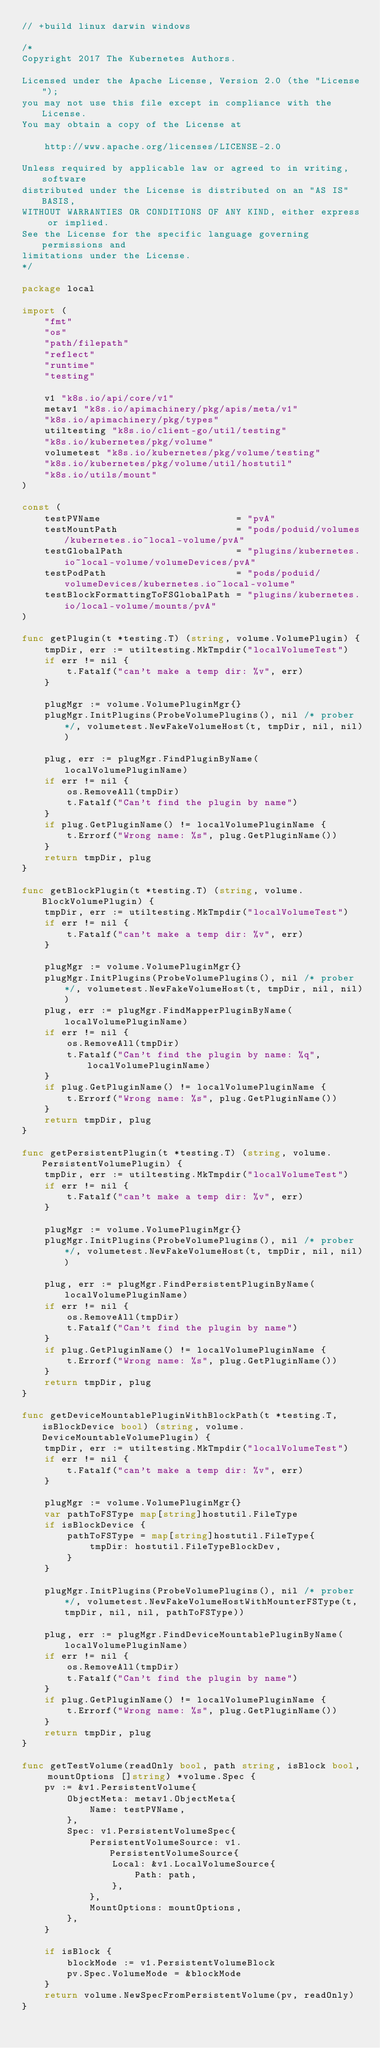Convert code to text. <code><loc_0><loc_0><loc_500><loc_500><_Go_>// +build linux darwin windows

/*
Copyright 2017 The Kubernetes Authors.

Licensed under the Apache License, Version 2.0 (the "License");
you may not use this file except in compliance with the License.
You may obtain a copy of the License at

    http://www.apache.org/licenses/LICENSE-2.0

Unless required by applicable law or agreed to in writing, software
distributed under the License is distributed on an "AS IS" BASIS,
WITHOUT WARRANTIES OR CONDITIONS OF ANY KIND, either express or implied.
See the License for the specific language governing permissions and
limitations under the License.
*/

package local

import (
	"fmt"
	"os"
	"path/filepath"
	"reflect"
	"runtime"
	"testing"

	v1 "k8s.io/api/core/v1"
	metav1 "k8s.io/apimachinery/pkg/apis/meta/v1"
	"k8s.io/apimachinery/pkg/types"
	utiltesting "k8s.io/client-go/util/testing"
	"k8s.io/kubernetes/pkg/volume"
	volumetest "k8s.io/kubernetes/pkg/volume/testing"
	"k8s.io/kubernetes/pkg/volume/util/hostutil"
	"k8s.io/utils/mount"
)

const (
	testPVName                        = "pvA"
	testMountPath                     = "pods/poduid/volumes/kubernetes.io~local-volume/pvA"
	testGlobalPath                    = "plugins/kubernetes.io~local-volume/volumeDevices/pvA"
	testPodPath                       = "pods/poduid/volumeDevices/kubernetes.io~local-volume"
	testBlockFormattingToFSGlobalPath = "plugins/kubernetes.io/local-volume/mounts/pvA"
)

func getPlugin(t *testing.T) (string, volume.VolumePlugin) {
	tmpDir, err := utiltesting.MkTmpdir("localVolumeTest")
	if err != nil {
		t.Fatalf("can't make a temp dir: %v", err)
	}

	plugMgr := volume.VolumePluginMgr{}
	plugMgr.InitPlugins(ProbeVolumePlugins(), nil /* prober */, volumetest.NewFakeVolumeHost(t, tmpDir, nil, nil))

	plug, err := plugMgr.FindPluginByName(localVolumePluginName)
	if err != nil {
		os.RemoveAll(tmpDir)
		t.Fatalf("Can't find the plugin by name")
	}
	if plug.GetPluginName() != localVolumePluginName {
		t.Errorf("Wrong name: %s", plug.GetPluginName())
	}
	return tmpDir, plug
}

func getBlockPlugin(t *testing.T) (string, volume.BlockVolumePlugin) {
	tmpDir, err := utiltesting.MkTmpdir("localVolumeTest")
	if err != nil {
		t.Fatalf("can't make a temp dir: %v", err)
	}

	plugMgr := volume.VolumePluginMgr{}
	plugMgr.InitPlugins(ProbeVolumePlugins(), nil /* prober */, volumetest.NewFakeVolumeHost(t, tmpDir, nil, nil))
	plug, err := plugMgr.FindMapperPluginByName(localVolumePluginName)
	if err != nil {
		os.RemoveAll(tmpDir)
		t.Fatalf("Can't find the plugin by name: %q", localVolumePluginName)
	}
	if plug.GetPluginName() != localVolumePluginName {
		t.Errorf("Wrong name: %s", plug.GetPluginName())
	}
	return tmpDir, plug
}

func getPersistentPlugin(t *testing.T) (string, volume.PersistentVolumePlugin) {
	tmpDir, err := utiltesting.MkTmpdir("localVolumeTest")
	if err != nil {
		t.Fatalf("can't make a temp dir: %v", err)
	}

	plugMgr := volume.VolumePluginMgr{}
	plugMgr.InitPlugins(ProbeVolumePlugins(), nil /* prober */, volumetest.NewFakeVolumeHost(t, tmpDir, nil, nil))

	plug, err := plugMgr.FindPersistentPluginByName(localVolumePluginName)
	if err != nil {
		os.RemoveAll(tmpDir)
		t.Fatalf("Can't find the plugin by name")
	}
	if plug.GetPluginName() != localVolumePluginName {
		t.Errorf("Wrong name: %s", plug.GetPluginName())
	}
	return tmpDir, plug
}

func getDeviceMountablePluginWithBlockPath(t *testing.T, isBlockDevice bool) (string, volume.DeviceMountableVolumePlugin) {
	tmpDir, err := utiltesting.MkTmpdir("localVolumeTest")
	if err != nil {
		t.Fatalf("can't make a temp dir: %v", err)
	}

	plugMgr := volume.VolumePluginMgr{}
	var pathToFSType map[string]hostutil.FileType
	if isBlockDevice {
		pathToFSType = map[string]hostutil.FileType{
			tmpDir: hostutil.FileTypeBlockDev,
		}
	}

	plugMgr.InitPlugins(ProbeVolumePlugins(), nil /* prober */, volumetest.NewFakeVolumeHostWithMounterFSType(t, tmpDir, nil, nil, pathToFSType))

	plug, err := plugMgr.FindDeviceMountablePluginByName(localVolumePluginName)
	if err != nil {
		os.RemoveAll(tmpDir)
		t.Fatalf("Can't find the plugin by name")
	}
	if plug.GetPluginName() != localVolumePluginName {
		t.Errorf("Wrong name: %s", plug.GetPluginName())
	}
	return tmpDir, plug
}

func getTestVolume(readOnly bool, path string, isBlock bool, mountOptions []string) *volume.Spec {
	pv := &v1.PersistentVolume{
		ObjectMeta: metav1.ObjectMeta{
			Name: testPVName,
		},
		Spec: v1.PersistentVolumeSpec{
			PersistentVolumeSource: v1.PersistentVolumeSource{
				Local: &v1.LocalVolumeSource{
					Path: path,
				},
			},
			MountOptions: mountOptions,
		},
	}

	if isBlock {
		blockMode := v1.PersistentVolumeBlock
		pv.Spec.VolumeMode = &blockMode
	}
	return volume.NewSpecFromPersistentVolume(pv, readOnly)
}
</code> 